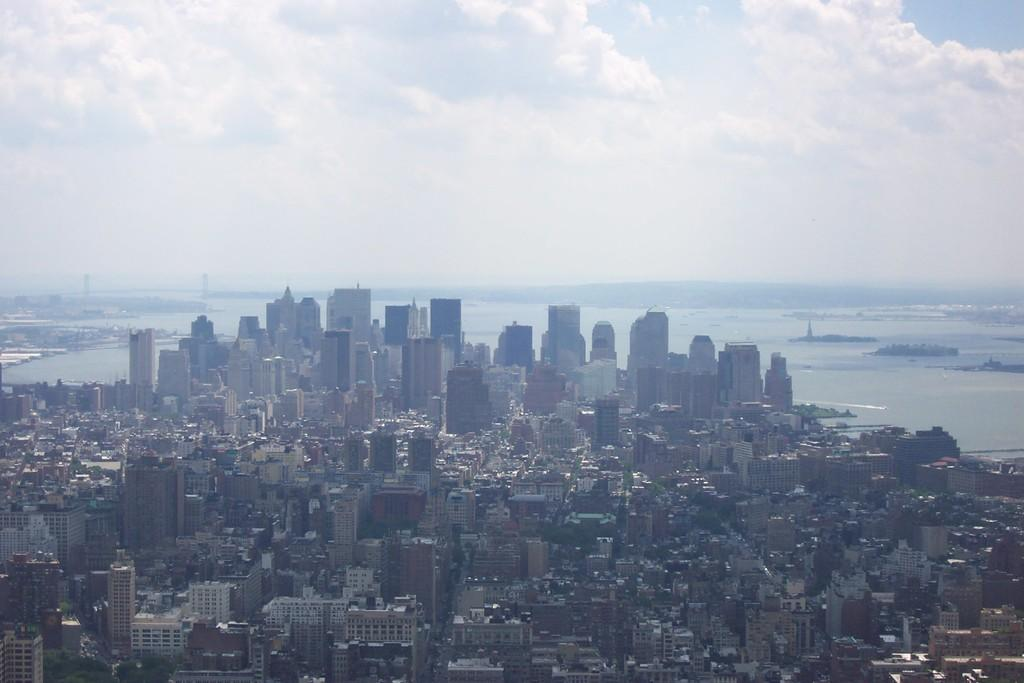What type of structures can be seen in the image? There are buildings in the image. What other natural elements are present in the image? There are trees in the image. What can be seen in the distance in the image? There is water visible in the background of the image. What else is visible in the background of the image? The sky is visible in the background of the image. What type of question is being asked by the cow in the image? There is no cow present in the image, so it is not possible to answer that question. 